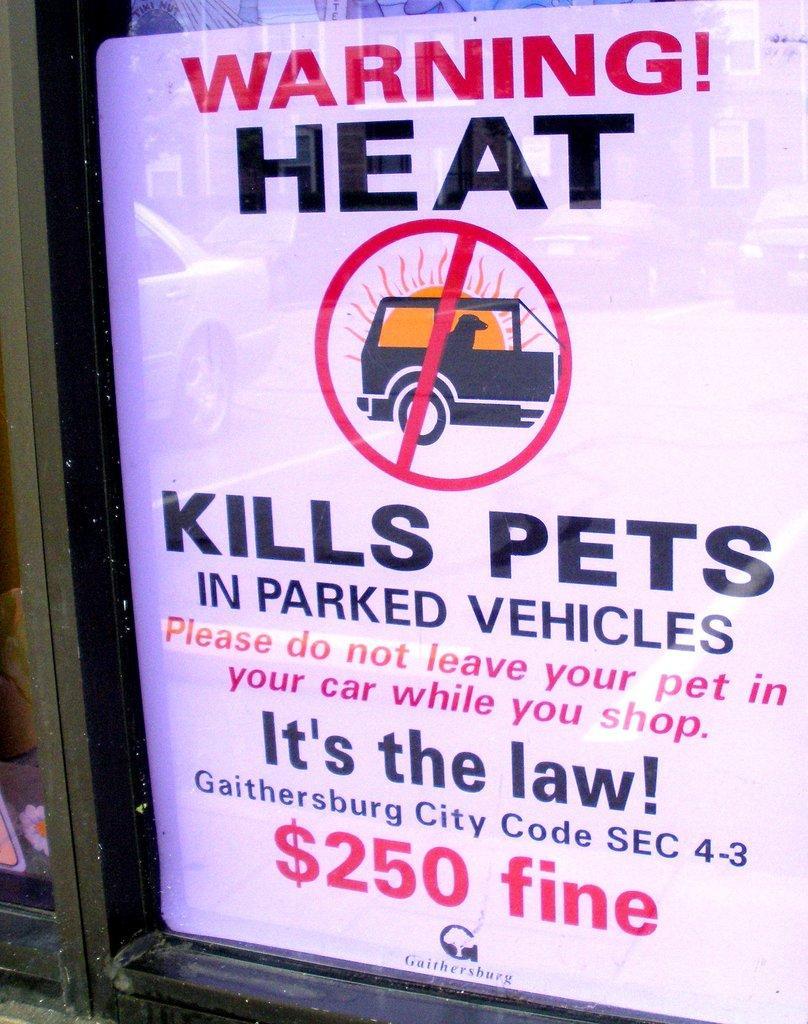Can you describe this image briefly? Here in this picture we can see a digital advertisement present over a place. 